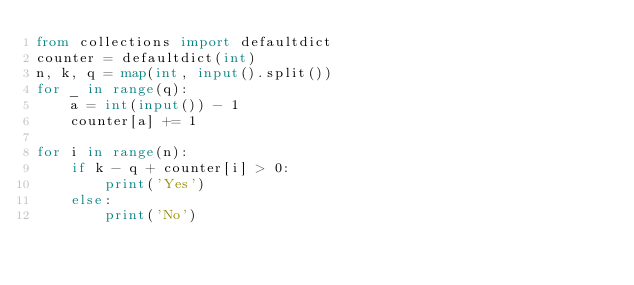<code> <loc_0><loc_0><loc_500><loc_500><_Python_>from collections import defaultdict
counter = defaultdict(int)
n, k, q = map(int, input().split())
for _ in range(q):
    a = int(input()) - 1
    counter[a] += 1

for i in range(n):
    if k - q + counter[i] > 0:
        print('Yes')
    else:
        print('No')</code> 